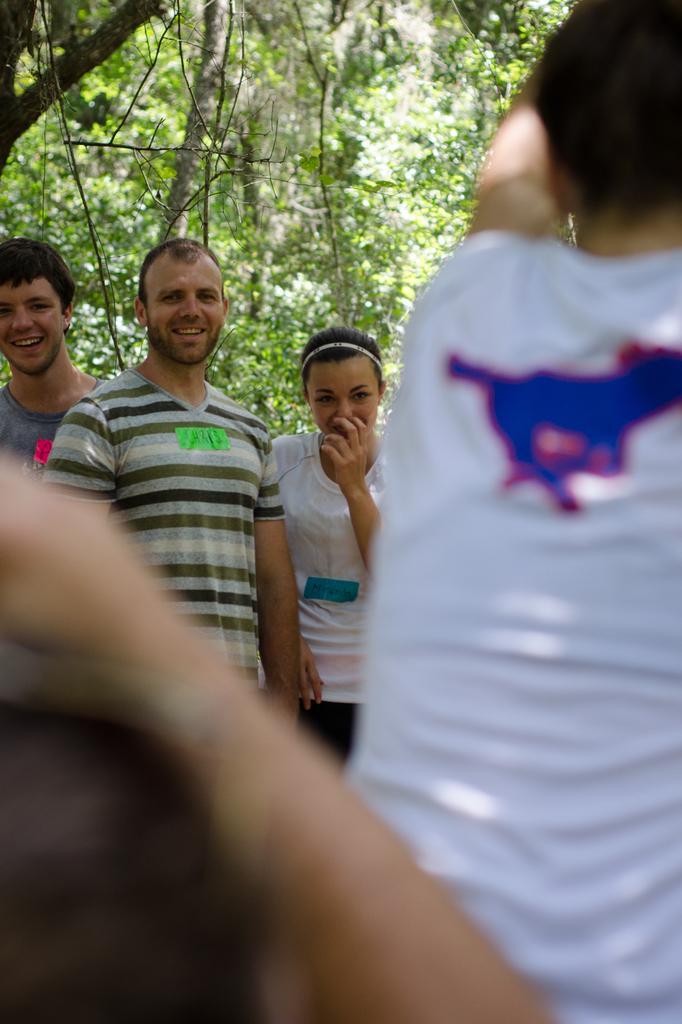In one or two sentences, can you explain what this image depicts? In this image we can see people. In the background there are trees. 